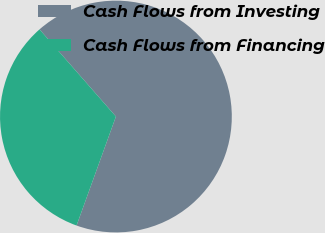Convert chart to OTSL. <chart><loc_0><loc_0><loc_500><loc_500><pie_chart><fcel>Cash Flows from Investing<fcel>Cash Flows from Financing<nl><fcel>66.97%<fcel>33.03%<nl></chart> 